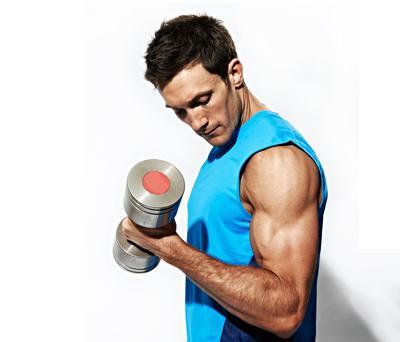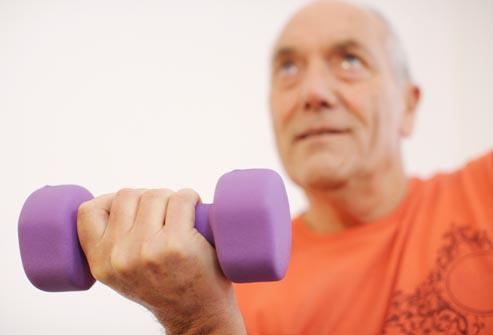The first image is the image on the left, the second image is the image on the right. Analyze the images presented: Is the assertion "An image shows a man holding identical weights in each hand." valid? Answer yes or no. No. 